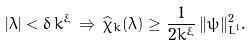<formula> <loc_0><loc_0><loc_500><loc_500>| \lambda | < \delta \, k ^ { \xi } \, \Rightarrow \, \widehat { \chi } _ { k } ( \lambda ) \geq \frac { 1 } { 2 k ^ { \xi } } \, \| \psi \| _ { L ^ { 1 } } ^ { 2 } .</formula> 